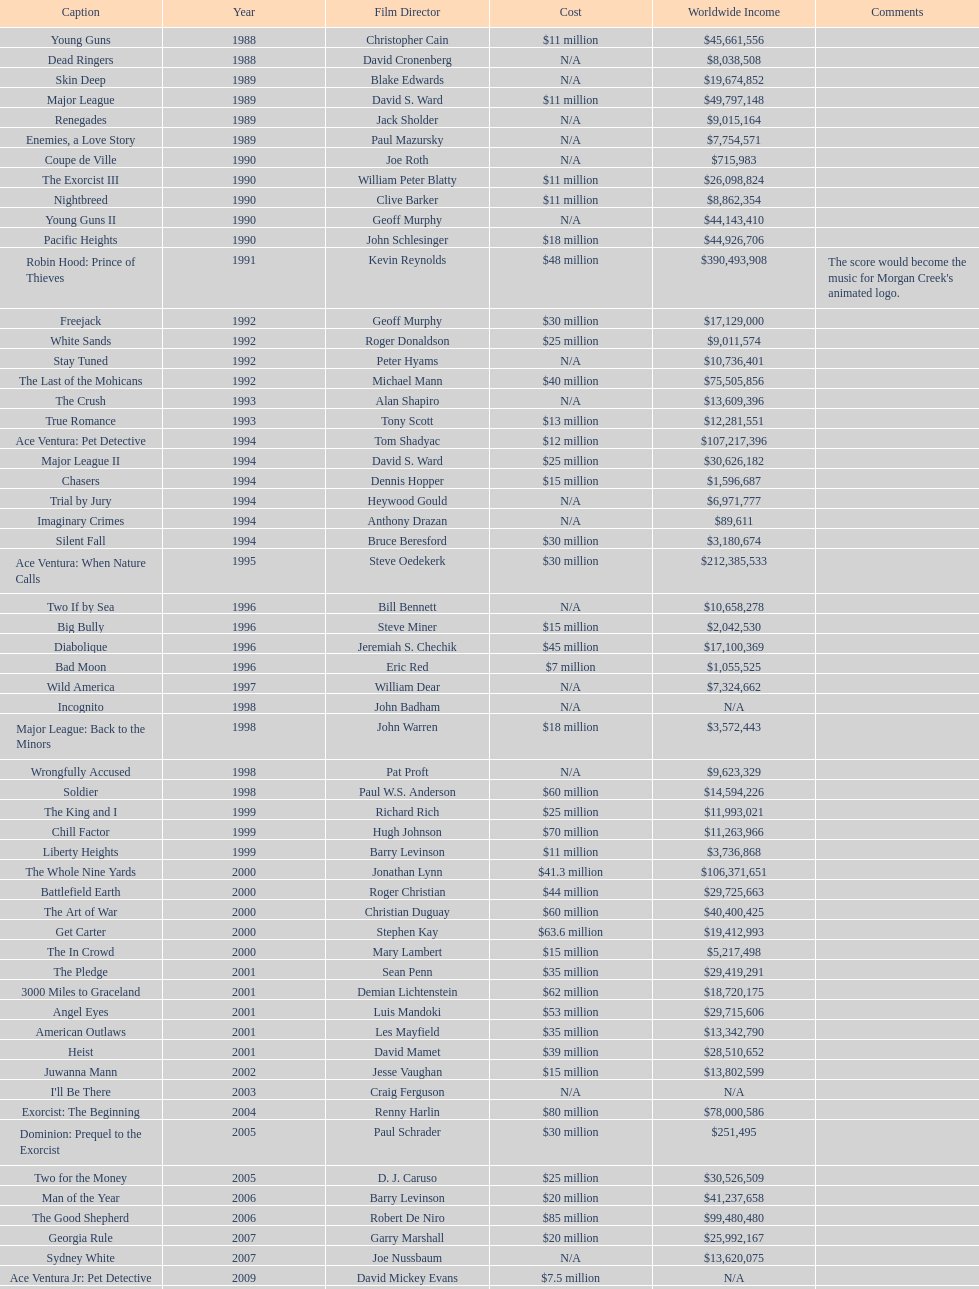What motion picture was created just prior to the pledge? The In Crowd. 